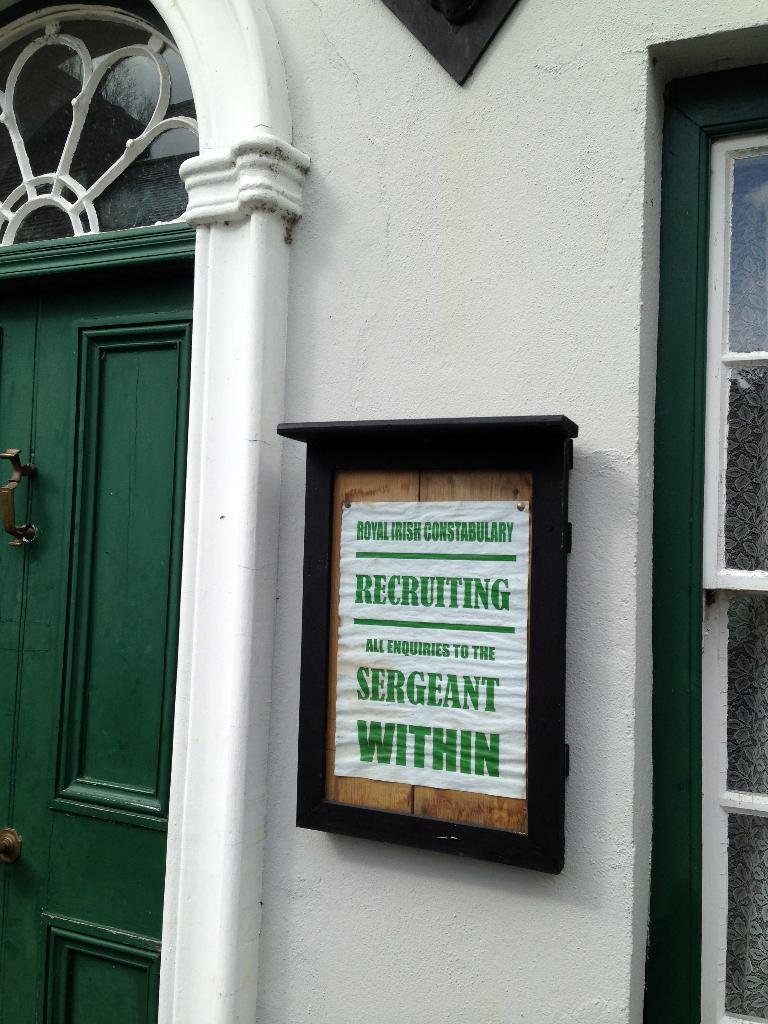What is one of the architectural features visible in the image? There is a wall in the image. What is the color of the door in the image? The door in the image is green. What other opening can be seen in the image? There is a window in the image. What is attached to the wall in the image? There is a board attached to the wall in the image. Are there any square plantations visible in the image? There are no square plantations present in the image. What type of rest can be seen in the image? There is no rest or resting area visible in the image; it primarily features architectural elements. 